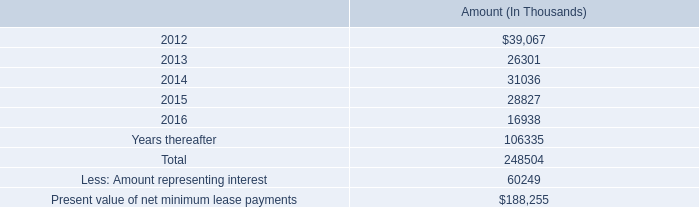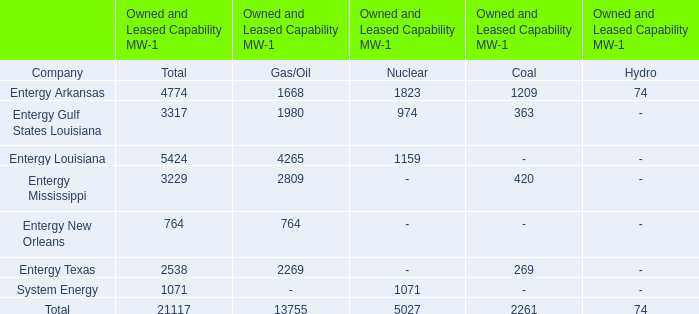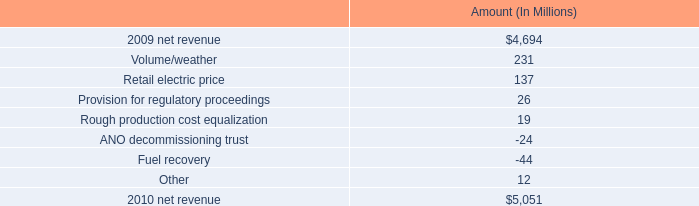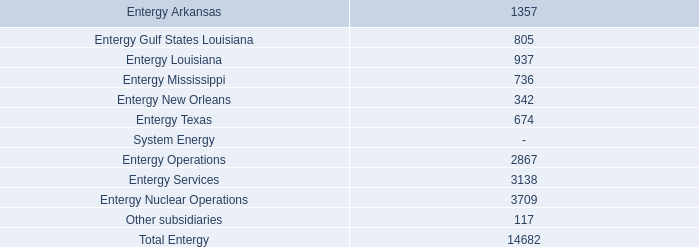what portion of the net change in net revenue is due to the retail electric price? 
Computations: (137 / (5051 - 4694))
Answer: 0.38375. 